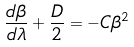<formula> <loc_0><loc_0><loc_500><loc_500>\frac { d \beta } { d \lambda } + \frac { D } { 2 } = - C \beta ^ { 2 }</formula> 